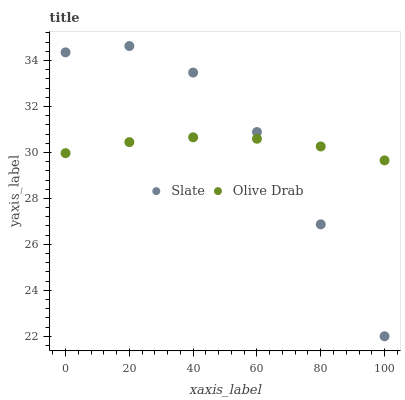Does Olive Drab have the minimum area under the curve?
Answer yes or no. Yes. Does Slate have the maximum area under the curve?
Answer yes or no. Yes. Does Olive Drab have the maximum area under the curve?
Answer yes or no. No. Is Olive Drab the smoothest?
Answer yes or no. Yes. Is Slate the roughest?
Answer yes or no. Yes. Is Olive Drab the roughest?
Answer yes or no. No. Does Slate have the lowest value?
Answer yes or no. Yes. Does Olive Drab have the lowest value?
Answer yes or no. No. Does Slate have the highest value?
Answer yes or no. Yes. Does Olive Drab have the highest value?
Answer yes or no. No. Does Olive Drab intersect Slate?
Answer yes or no. Yes. Is Olive Drab less than Slate?
Answer yes or no. No. Is Olive Drab greater than Slate?
Answer yes or no. No. 